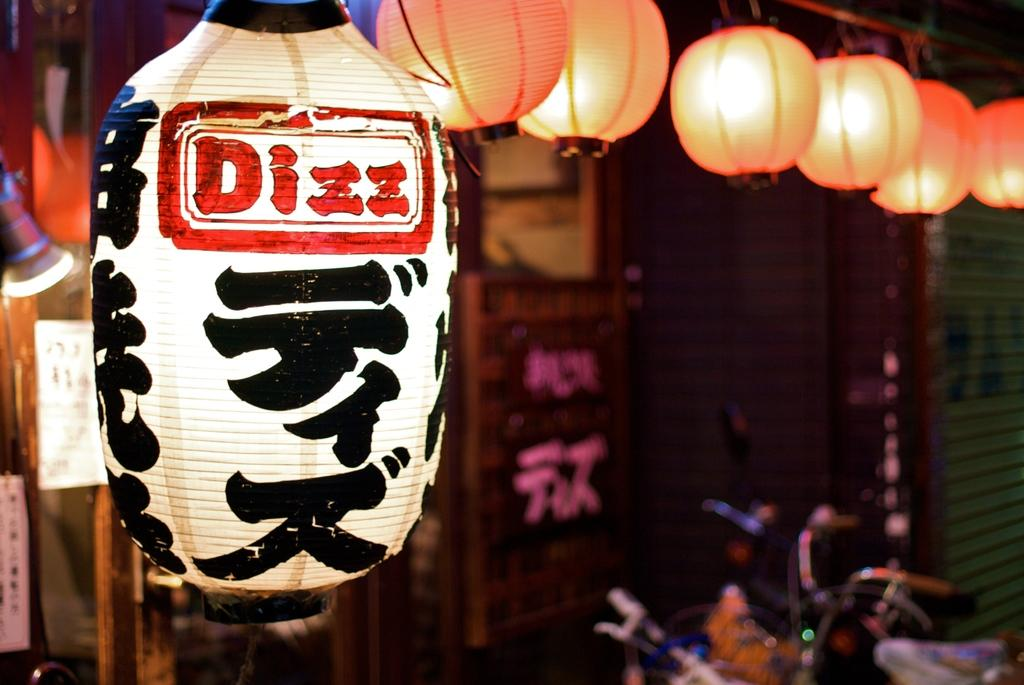What is the main object in the middle of the image? There is a big light in the middle of the image. What can be seen at the top of the image? There are many lights at the top of the image. How many bears are sitting on the stem in the image? There are no bears or stems present in the image. 